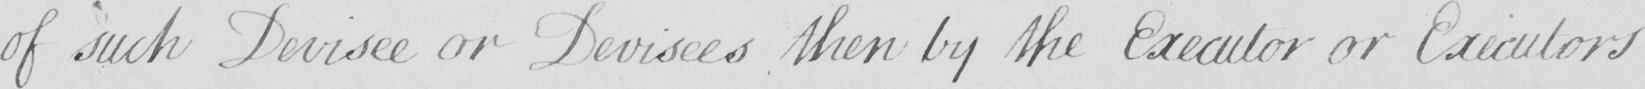Can you read and transcribe this handwriting? of such Devisee or Devisees then by the Executor or Executors 